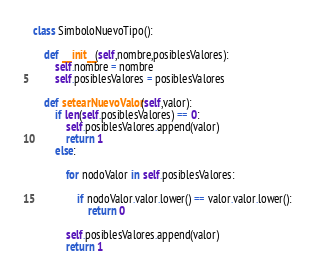<code> <loc_0><loc_0><loc_500><loc_500><_Python_>class SimboloNuevoTipo():

    def __init__(self,nombre,posiblesValores):
        self.nombre = nombre
        self.posiblesValores = posiblesValores

    def setearNuevoValor(self,valor):
        if len(self.posiblesValores) == 0:
            self.posiblesValores.append(valor)            
            return 1
        else:

            for nodoValor in self.posiblesValores:

                if nodoValor.valor.lower() == valor.valor.lower():
                    return 0
            
            self.posiblesValores.append(valor)
            return 1</code> 